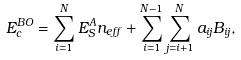Convert formula to latex. <formula><loc_0><loc_0><loc_500><loc_500>E _ { c } ^ { B O } = \sum _ { i = 1 } ^ { N } E _ { S } ^ { A } n _ { e f f } + \sum _ { i = 1 } ^ { N - 1 } \sum _ { j = i + 1 } ^ { N } a _ { i j } B _ { i j } ,</formula> 